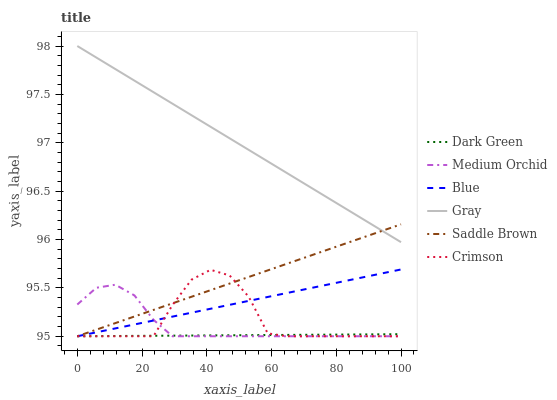Does Dark Green have the minimum area under the curve?
Answer yes or no. Yes. Does Gray have the maximum area under the curve?
Answer yes or no. Yes. Does Medium Orchid have the minimum area under the curve?
Answer yes or no. No. Does Medium Orchid have the maximum area under the curve?
Answer yes or no. No. Is Gray the smoothest?
Answer yes or no. Yes. Is Crimson the roughest?
Answer yes or no. Yes. Is Medium Orchid the smoothest?
Answer yes or no. No. Is Medium Orchid the roughest?
Answer yes or no. No. Does Blue have the lowest value?
Answer yes or no. Yes. Does Gray have the lowest value?
Answer yes or no. No. Does Gray have the highest value?
Answer yes or no. Yes. Does Medium Orchid have the highest value?
Answer yes or no. No. Is Dark Green less than Gray?
Answer yes or no. Yes. Is Gray greater than Crimson?
Answer yes or no. Yes. Does Saddle Brown intersect Medium Orchid?
Answer yes or no. Yes. Is Saddle Brown less than Medium Orchid?
Answer yes or no. No. Is Saddle Brown greater than Medium Orchid?
Answer yes or no. No. Does Dark Green intersect Gray?
Answer yes or no. No. 